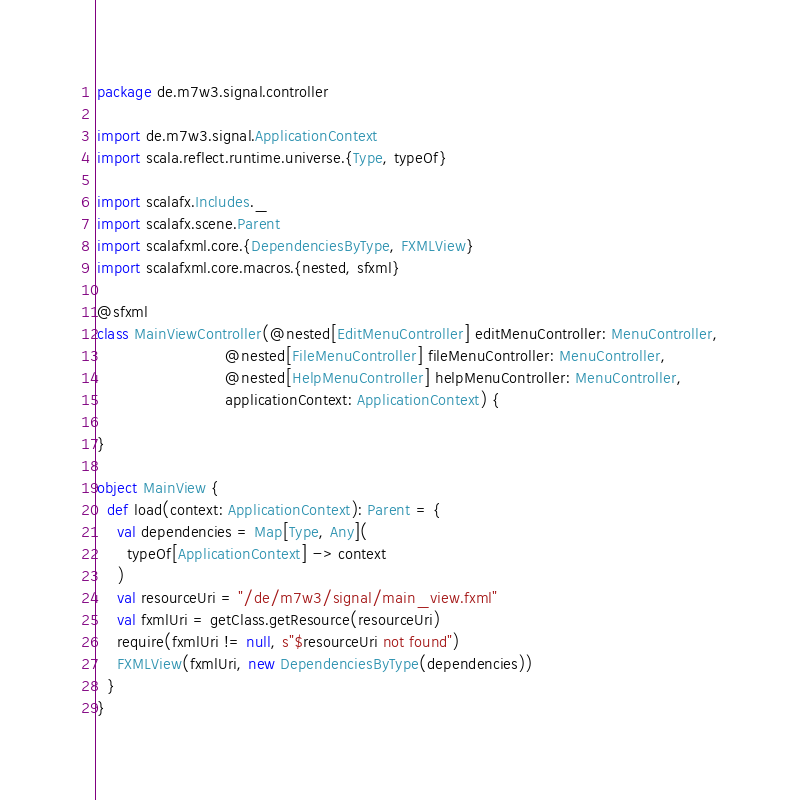Convert code to text. <code><loc_0><loc_0><loc_500><loc_500><_Scala_>package de.m7w3.signal.controller

import de.m7w3.signal.ApplicationContext
import scala.reflect.runtime.universe.{Type, typeOf}

import scalafx.Includes._
import scalafx.scene.Parent
import scalafxml.core.{DependenciesByType, FXMLView}
import scalafxml.core.macros.{nested, sfxml}

@sfxml
class MainViewController(@nested[EditMenuController] editMenuController: MenuController,
                          @nested[FileMenuController] fileMenuController: MenuController,
                          @nested[HelpMenuController] helpMenuController: MenuController,
                          applicationContext: ApplicationContext) {

}

object MainView {
  def load(context: ApplicationContext): Parent = {
    val dependencies = Map[Type, Any](
      typeOf[ApplicationContext] -> context
    )
    val resourceUri = "/de/m7w3/signal/main_view.fxml"
    val fxmlUri = getClass.getResource(resourceUri)
    require(fxmlUri != null, s"$resourceUri not found")
    FXMLView(fxmlUri, new DependenciesByType(dependencies))
  }
}
</code> 